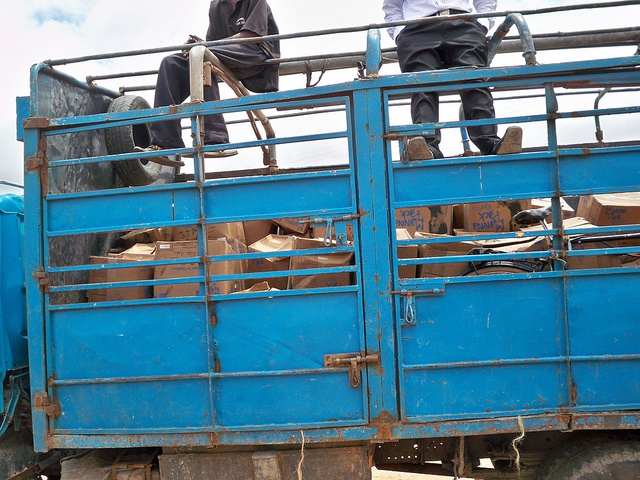Describe the objects in this image and their specific colors. I can see truck in teal, gray, black, and white tones, people in white, black, gray, and darkgray tones, and people in white, black, gray, and lavender tones in this image. 